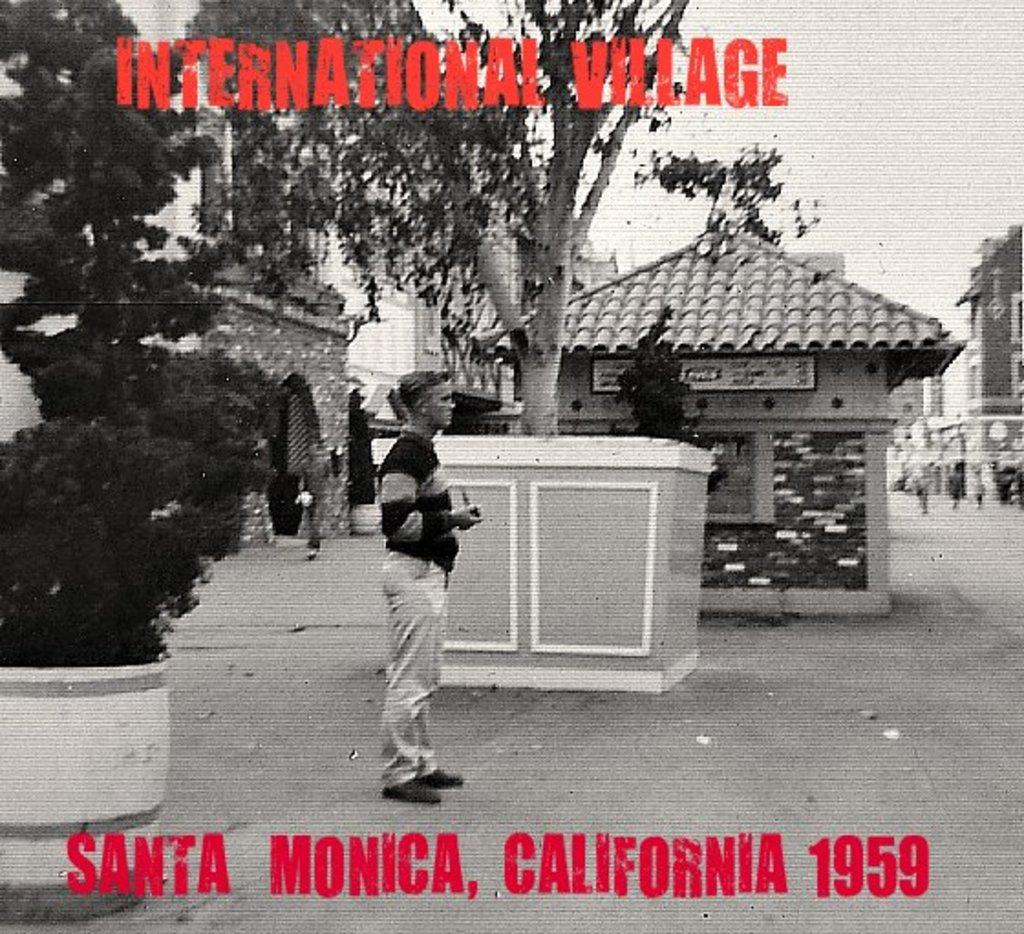What can be seen on the poster in the image? There is something written on the poster, and trees, buildings, and a person are visible on it. Can you describe the person depicted on the poster? Unfortunately, the provided facts do not give enough information to describe the person depicted on the poster. What type of setting is shown on the poster? The poster features a combination of natural elements (trees) and man-made structures (buildings). What type of record is being played by the person on the poster? There is no record or person playing a record present on the poster; it only features a person, trees, buildings, and something written. 